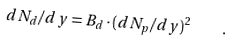<formula> <loc_0><loc_0><loc_500><loc_500>d N _ { d } / d y = B _ { d } \cdot ( d N _ { p } / d y ) ^ { 2 } \quad .</formula> 